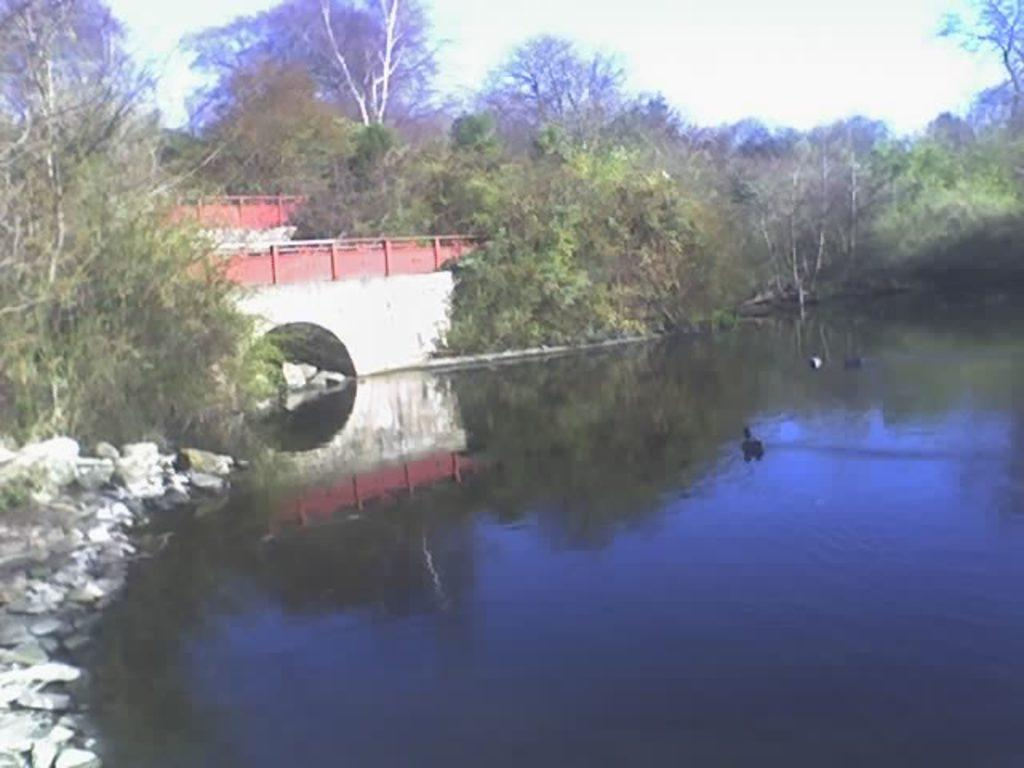What can be seen in the foreground of the image? In the foreground of the image, there are trees, a pond, stones, and a bridge. What is the natural element present in the foreground of the image? The natural element in the foreground of the image is the trees. What type of structure is present in the foreground of the image? There is a bridge in the foreground of the image. What is visible in the background of the image? The sky is visible in the image. Where is the seashore located in the image? There is no seashore present in the image. What type of party is taking place in the image? There is no party depicted in the image. 